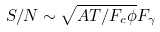<formula> <loc_0><loc_0><loc_500><loc_500>S / N \sim \sqrt { A T / F _ { c } \phi } F _ { \gamma }</formula> 